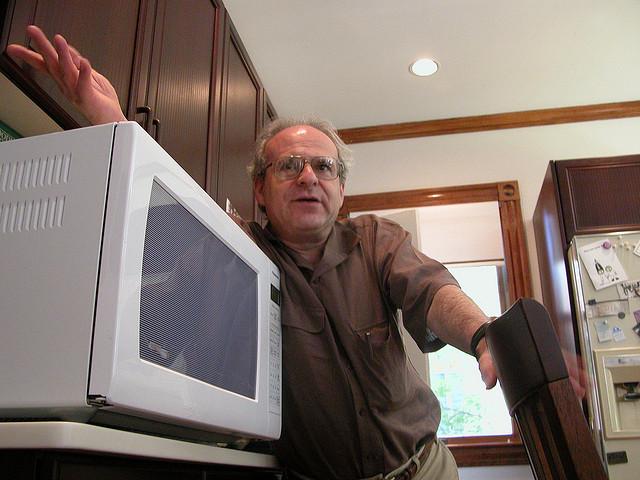What color is the man's watch?
Keep it brief. Black. Is this a recent picture?
Give a very brief answer. Yes. Is the man happy?
Short answer required. No. How many people are there?
Concise answer only. 1. What is the person leaning on?
Concise answer only. Microwave. How many lights are visible?
Give a very brief answer. 1. 